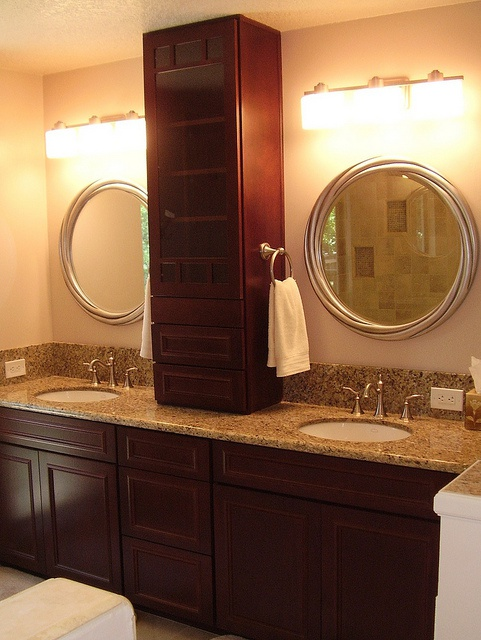Describe the objects in this image and their specific colors. I can see sink in tan, brown, and maroon tones and sink in tan, brown, and gray tones in this image. 